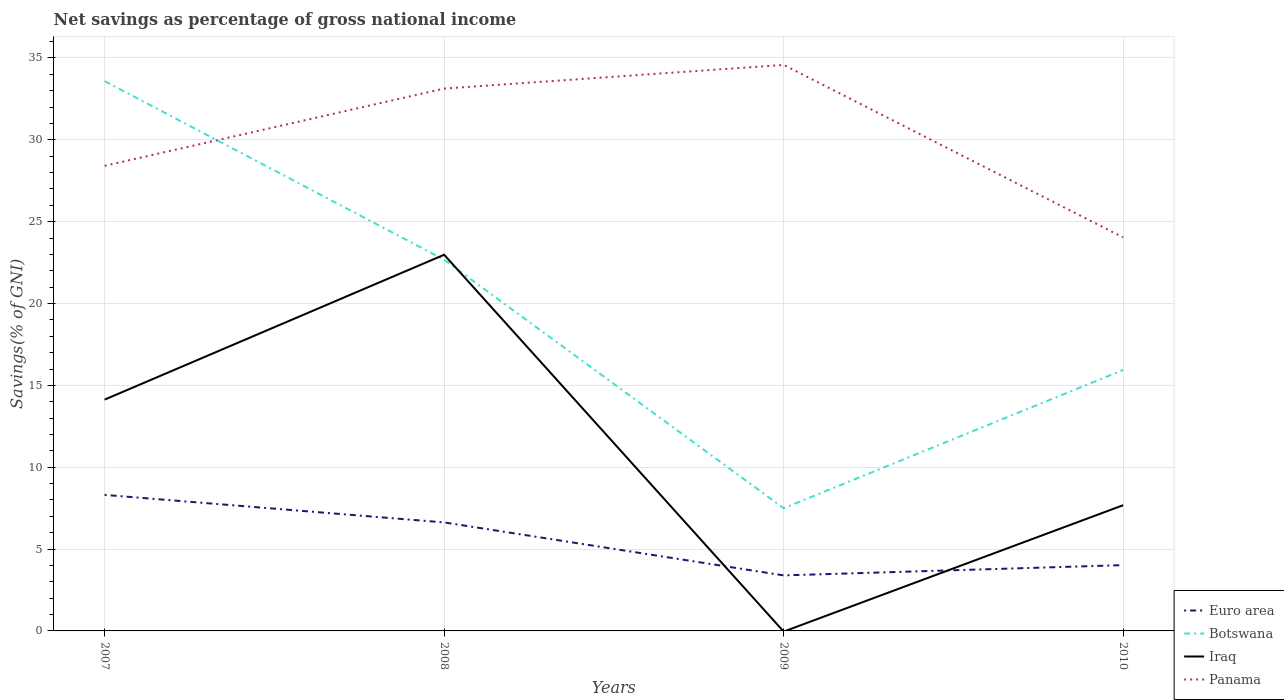How many different coloured lines are there?
Offer a very short reply. 4. Does the line corresponding to Euro area intersect with the line corresponding to Botswana?
Your answer should be very brief. No. Is the number of lines equal to the number of legend labels?
Your response must be concise. No. What is the total total savings in Euro area in the graph?
Provide a succinct answer. 1.68. What is the difference between the highest and the second highest total savings in Botswana?
Your answer should be compact. 26.09. Is the total savings in Botswana strictly greater than the total savings in Panama over the years?
Offer a very short reply. No. How many lines are there?
Provide a succinct answer. 4. How many years are there in the graph?
Your response must be concise. 4. What is the difference between two consecutive major ticks on the Y-axis?
Your answer should be very brief. 5. Are the values on the major ticks of Y-axis written in scientific E-notation?
Keep it short and to the point. No. Does the graph contain any zero values?
Keep it short and to the point. Yes. How are the legend labels stacked?
Ensure brevity in your answer.  Vertical. What is the title of the graph?
Keep it short and to the point. Net savings as percentage of gross national income. What is the label or title of the X-axis?
Offer a terse response. Years. What is the label or title of the Y-axis?
Offer a very short reply. Savings(% of GNI). What is the Savings(% of GNI) in Euro area in 2007?
Make the answer very short. 8.31. What is the Savings(% of GNI) of Botswana in 2007?
Your response must be concise. 33.59. What is the Savings(% of GNI) in Iraq in 2007?
Provide a short and direct response. 14.13. What is the Savings(% of GNI) in Panama in 2007?
Keep it short and to the point. 28.41. What is the Savings(% of GNI) in Euro area in 2008?
Offer a terse response. 6.63. What is the Savings(% of GNI) of Botswana in 2008?
Ensure brevity in your answer.  22.68. What is the Savings(% of GNI) in Iraq in 2008?
Keep it short and to the point. 22.98. What is the Savings(% of GNI) of Panama in 2008?
Offer a terse response. 33.13. What is the Savings(% of GNI) in Euro area in 2009?
Give a very brief answer. 3.39. What is the Savings(% of GNI) of Botswana in 2009?
Offer a very short reply. 7.5. What is the Savings(% of GNI) in Panama in 2009?
Your answer should be compact. 34.58. What is the Savings(% of GNI) in Euro area in 2010?
Ensure brevity in your answer.  4.02. What is the Savings(% of GNI) of Botswana in 2010?
Offer a terse response. 15.94. What is the Savings(% of GNI) of Iraq in 2010?
Your response must be concise. 7.68. What is the Savings(% of GNI) of Panama in 2010?
Your response must be concise. 24.04. Across all years, what is the maximum Savings(% of GNI) of Euro area?
Make the answer very short. 8.31. Across all years, what is the maximum Savings(% of GNI) of Botswana?
Your answer should be very brief. 33.59. Across all years, what is the maximum Savings(% of GNI) in Iraq?
Keep it short and to the point. 22.98. Across all years, what is the maximum Savings(% of GNI) of Panama?
Give a very brief answer. 34.58. Across all years, what is the minimum Savings(% of GNI) in Euro area?
Ensure brevity in your answer.  3.39. Across all years, what is the minimum Savings(% of GNI) of Botswana?
Ensure brevity in your answer.  7.5. Across all years, what is the minimum Savings(% of GNI) in Iraq?
Provide a short and direct response. 0. Across all years, what is the minimum Savings(% of GNI) of Panama?
Offer a very short reply. 24.04. What is the total Savings(% of GNI) of Euro area in the graph?
Ensure brevity in your answer.  22.35. What is the total Savings(% of GNI) of Botswana in the graph?
Provide a short and direct response. 79.7. What is the total Savings(% of GNI) of Iraq in the graph?
Provide a short and direct response. 44.79. What is the total Savings(% of GNI) of Panama in the graph?
Provide a short and direct response. 120.16. What is the difference between the Savings(% of GNI) of Euro area in 2007 and that in 2008?
Your response must be concise. 1.68. What is the difference between the Savings(% of GNI) in Botswana in 2007 and that in 2008?
Your answer should be compact. 10.91. What is the difference between the Savings(% of GNI) in Iraq in 2007 and that in 2008?
Your response must be concise. -8.85. What is the difference between the Savings(% of GNI) in Panama in 2007 and that in 2008?
Provide a short and direct response. -4.72. What is the difference between the Savings(% of GNI) in Euro area in 2007 and that in 2009?
Keep it short and to the point. 4.92. What is the difference between the Savings(% of GNI) in Botswana in 2007 and that in 2009?
Provide a succinct answer. 26.09. What is the difference between the Savings(% of GNI) in Panama in 2007 and that in 2009?
Offer a terse response. -6.16. What is the difference between the Savings(% of GNI) of Euro area in 2007 and that in 2010?
Offer a very short reply. 4.29. What is the difference between the Savings(% of GNI) in Botswana in 2007 and that in 2010?
Keep it short and to the point. 17.64. What is the difference between the Savings(% of GNI) of Iraq in 2007 and that in 2010?
Give a very brief answer. 6.45. What is the difference between the Savings(% of GNI) in Panama in 2007 and that in 2010?
Give a very brief answer. 4.37. What is the difference between the Savings(% of GNI) in Euro area in 2008 and that in 2009?
Provide a short and direct response. 3.24. What is the difference between the Savings(% of GNI) in Botswana in 2008 and that in 2009?
Your answer should be compact. 15.18. What is the difference between the Savings(% of GNI) of Panama in 2008 and that in 2009?
Provide a short and direct response. -1.45. What is the difference between the Savings(% of GNI) in Euro area in 2008 and that in 2010?
Your response must be concise. 2.61. What is the difference between the Savings(% of GNI) of Botswana in 2008 and that in 2010?
Provide a short and direct response. 6.74. What is the difference between the Savings(% of GNI) of Iraq in 2008 and that in 2010?
Your answer should be very brief. 15.3. What is the difference between the Savings(% of GNI) in Panama in 2008 and that in 2010?
Offer a very short reply. 9.09. What is the difference between the Savings(% of GNI) of Euro area in 2009 and that in 2010?
Provide a succinct answer. -0.63. What is the difference between the Savings(% of GNI) in Botswana in 2009 and that in 2010?
Your answer should be very brief. -8.45. What is the difference between the Savings(% of GNI) of Panama in 2009 and that in 2010?
Your answer should be very brief. 10.54. What is the difference between the Savings(% of GNI) of Euro area in 2007 and the Savings(% of GNI) of Botswana in 2008?
Provide a succinct answer. -14.37. What is the difference between the Savings(% of GNI) of Euro area in 2007 and the Savings(% of GNI) of Iraq in 2008?
Your response must be concise. -14.67. What is the difference between the Savings(% of GNI) of Euro area in 2007 and the Savings(% of GNI) of Panama in 2008?
Give a very brief answer. -24.82. What is the difference between the Savings(% of GNI) of Botswana in 2007 and the Savings(% of GNI) of Iraq in 2008?
Make the answer very short. 10.61. What is the difference between the Savings(% of GNI) of Botswana in 2007 and the Savings(% of GNI) of Panama in 2008?
Your response must be concise. 0.45. What is the difference between the Savings(% of GNI) of Iraq in 2007 and the Savings(% of GNI) of Panama in 2008?
Offer a very short reply. -19. What is the difference between the Savings(% of GNI) in Euro area in 2007 and the Savings(% of GNI) in Botswana in 2009?
Make the answer very short. 0.82. What is the difference between the Savings(% of GNI) in Euro area in 2007 and the Savings(% of GNI) in Panama in 2009?
Your answer should be compact. -26.27. What is the difference between the Savings(% of GNI) in Botswana in 2007 and the Savings(% of GNI) in Panama in 2009?
Provide a succinct answer. -0.99. What is the difference between the Savings(% of GNI) of Iraq in 2007 and the Savings(% of GNI) of Panama in 2009?
Provide a succinct answer. -20.45. What is the difference between the Savings(% of GNI) in Euro area in 2007 and the Savings(% of GNI) in Botswana in 2010?
Your response must be concise. -7.63. What is the difference between the Savings(% of GNI) in Euro area in 2007 and the Savings(% of GNI) in Iraq in 2010?
Offer a terse response. 0.63. What is the difference between the Savings(% of GNI) of Euro area in 2007 and the Savings(% of GNI) of Panama in 2010?
Give a very brief answer. -15.73. What is the difference between the Savings(% of GNI) of Botswana in 2007 and the Savings(% of GNI) of Iraq in 2010?
Your answer should be very brief. 25.9. What is the difference between the Savings(% of GNI) in Botswana in 2007 and the Savings(% of GNI) in Panama in 2010?
Make the answer very short. 9.55. What is the difference between the Savings(% of GNI) in Iraq in 2007 and the Savings(% of GNI) in Panama in 2010?
Your answer should be compact. -9.91. What is the difference between the Savings(% of GNI) in Euro area in 2008 and the Savings(% of GNI) in Botswana in 2009?
Your answer should be very brief. -0.87. What is the difference between the Savings(% of GNI) of Euro area in 2008 and the Savings(% of GNI) of Panama in 2009?
Provide a short and direct response. -27.95. What is the difference between the Savings(% of GNI) of Botswana in 2008 and the Savings(% of GNI) of Panama in 2009?
Offer a terse response. -11.9. What is the difference between the Savings(% of GNI) in Iraq in 2008 and the Savings(% of GNI) in Panama in 2009?
Give a very brief answer. -11.6. What is the difference between the Savings(% of GNI) of Euro area in 2008 and the Savings(% of GNI) of Botswana in 2010?
Make the answer very short. -9.31. What is the difference between the Savings(% of GNI) of Euro area in 2008 and the Savings(% of GNI) of Iraq in 2010?
Offer a terse response. -1.05. What is the difference between the Savings(% of GNI) in Euro area in 2008 and the Savings(% of GNI) in Panama in 2010?
Your answer should be compact. -17.41. What is the difference between the Savings(% of GNI) of Botswana in 2008 and the Savings(% of GNI) of Iraq in 2010?
Your answer should be compact. 15. What is the difference between the Savings(% of GNI) of Botswana in 2008 and the Savings(% of GNI) of Panama in 2010?
Keep it short and to the point. -1.36. What is the difference between the Savings(% of GNI) of Iraq in 2008 and the Savings(% of GNI) of Panama in 2010?
Give a very brief answer. -1.06. What is the difference between the Savings(% of GNI) in Euro area in 2009 and the Savings(% of GNI) in Botswana in 2010?
Offer a terse response. -12.55. What is the difference between the Savings(% of GNI) in Euro area in 2009 and the Savings(% of GNI) in Iraq in 2010?
Ensure brevity in your answer.  -4.29. What is the difference between the Savings(% of GNI) in Euro area in 2009 and the Savings(% of GNI) in Panama in 2010?
Ensure brevity in your answer.  -20.65. What is the difference between the Savings(% of GNI) in Botswana in 2009 and the Savings(% of GNI) in Iraq in 2010?
Provide a short and direct response. -0.19. What is the difference between the Savings(% of GNI) in Botswana in 2009 and the Savings(% of GNI) in Panama in 2010?
Your answer should be compact. -16.54. What is the average Savings(% of GNI) in Euro area per year?
Provide a succinct answer. 5.59. What is the average Savings(% of GNI) in Botswana per year?
Provide a short and direct response. 19.92. What is the average Savings(% of GNI) in Iraq per year?
Ensure brevity in your answer.  11.2. What is the average Savings(% of GNI) of Panama per year?
Ensure brevity in your answer.  30.04. In the year 2007, what is the difference between the Savings(% of GNI) of Euro area and Savings(% of GNI) of Botswana?
Keep it short and to the point. -25.28. In the year 2007, what is the difference between the Savings(% of GNI) of Euro area and Savings(% of GNI) of Iraq?
Your answer should be very brief. -5.82. In the year 2007, what is the difference between the Savings(% of GNI) of Euro area and Savings(% of GNI) of Panama?
Your response must be concise. -20.1. In the year 2007, what is the difference between the Savings(% of GNI) in Botswana and Savings(% of GNI) in Iraq?
Provide a short and direct response. 19.46. In the year 2007, what is the difference between the Savings(% of GNI) in Botswana and Savings(% of GNI) in Panama?
Your answer should be compact. 5.17. In the year 2007, what is the difference between the Savings(% of GNI) of Iraq and Savings(% of GNI) of Panama?
Make the answer very short. -14.28. In the year 2008, what is the difference between the Savings(% of GNI) in Euro area and Savings(% of GNI) in Botswana?
Make the answer very short. -16.05. In the year 2008, what is the difference between the Savings(% of GNI) of Euro area and Savings(% of GNI) of Iraq?
Your answer should be very brief. -16.35. In the year 2008, what is the difference between the Savings(% of GNI) of Euro area and Savings(% of GNI) of Panama?
Offer a very short reply. -26.5. In the year 2008, what is the difference between the Savings(% of GNI) of Botswana and Savings(% of GNI) of Iraq?
Provide a succinct answer. -0.3. In the year 2008, what is the difference between the Savings(% of GNI) in Botswana and Savings(% of GNI) in Panama?
Offer a very short reply. -10.45. In the year 2008, what is the difference between the Savings(% of GNI) in Iraq and Savings(% of GNI) in Panama?
Your answer should be very brief. -10.15. In the year 2009, what is the difference between the Savings(% of GNI) in Euro area and Savings(% of GNI) in Botswana?
Provide a succinct answer. -4.1. In the year 2009, what is the difference between the Savings(% of GNI) in Euro area and Savings(% of GNI) in Panama?
Your response must be concise. -31.19. In the year 2009, what is the difference between the Savings(% of GNI) in Botswana and Savings(% of GNI) in Panama?
Your answer should be compact. -27.08. In the year 2010, what is the difference between the Savings(% of GNI) in Euro area and Savings(% of GNI) in Botswana?
Provide a short and direct response. -11.92. In the year 2010, what is the difference between the Savings(% of GNI) of Euro area and Savings(% of GNI) of Iraq?
Offer a terse response. -3.66. In the year 2010, what is the difference between the Savings(% of GNI) of Euro area and Savings(% of GNI) of Panama?
Ensure brevity in your answer.  -20.02. In the year 2010, what is the difference between the Savings(% of GNI) in Botswana and Savings(% of GNI) in Iraq?
Keep it short and to the point. 8.26. In the year 2010, what is the difference between the Savings(% of GNI) of Botswana and Savings(% of GNI) of Panama?
Provide a succinct answer. -8.1. In the year 2010, what is the difference between the Savings(% of GNI) of Iraq and Savings(% of GNI) of Panama?
Ensure brevity in your answer.  -16.36. What is the ratio of the Savings(% of GNI) in Euro area in 2007 to that in 2008?
Your response must be concise. 1.25. What is the ratio of the Savings(% of GNI) of Botswana in 2007 to that in 2008?
Give a very brief answer. 1.48. What is the ratio of the Savings(% of GNI) of Iraq in 2007 to that in 2008?
Your answer should be compact. 0.61. What is the ratio of the Savings(% of GNI) in Panama in 2007 to that in 2008?
Your answer should be very brief. 0.86. What is the ratio of the Savings(% of GNI) in Euro area in 2007 to that in 2009?
Your answer should be very brief. 2.45. What is the ratio of the Savings(% of GNI) of Botswana in 2007 to that in 2009?
Offer a very short reply. 4.48. What is the ratio of the Savings(% of GNI) in Panama in 2007 to that in 2009?
Make the answer very short. 0.82. What is the ratio of the Savings(% of GNI) in Euro area in 2007 to that in 2010?
Keep it short and to the point. 2.07. What is the ratio of the Savings(% of GNI) of Botswana in 2007 to that in 2010?
Your response must be concise. 2.11. What is the ratio of the Savings(% of GNI) of Iraq in 2007 to that in 2010?
Your answer should be very brief. 1.84. What is the ratio of the Savings(% of GNI) of Panama in 2007 to that in 2010?
Your answer should be compact. 1.18. What is the ratio of the Savings(% of GNI) in Euro area in 2008 to that in 2009?
Your answer should be very brief. 1.95. What is the ratio of the Savings(% of GNI) in Botswana in 2008 to that in 2009?
Ensure brevity in your answer.  3.03. What is the ratio of the Savings(% of GNI) in Panama in 2008 to that in 2009?
Give a very brief answer. 0.96. What is the ratio of the Savings(% of GNI) of Euro area in 2008 to that in 2010?
Provide a short and direct response. 1.65. What is the ratio of the Savings(% of GNI) in Botswana in 2008 to that in 2010?
Give a very brief answer. 1.42. What is the ratio of the Savings(% of GNI) of Iraq in 2008 to that in 2010?
Offer a terse response. 2.99. What is the ratio of the Savings(% of GNI) of Panama in 2008 to that in 2010?
Keep it short and to the point. 1.38. What is the ratio of the Savings(% of GNI) of Euro area in 2009 to that in 2010?
Provide a short and direct response. 0.84. What is the ratio of the Savings(% of GNI) of Botswana in 2009 to that in 2010?
Offer a terse response. 0.47. What is the ratio of the Savings(% of GNI) of Panama in 2009 to that in 2010?
Provide a short and direct response. 1.44. What is the difference between the highest and the second highest Savings(% of GNI) in Euro area?
Ensure brevity in your answer.  1.68. What is the difference between the highest and the second highest Savings(% of GNI) in Botswana?
Offer a terse response. 10.91. What is the difference between the highest and the second highest Savings(% of GNI) of Iraq?
Provide a succinct answer. 8.85. What is the difference between the highest and the second highest Savings(% of GNI) in Panama?
Your answer should be compact. 1.45. What is the difference between the highest and the lowest Savings(% of GNI) in Euro area?
Provide a succinct answer. 4.92. What is the difference between the highest and the lowest Savings(% of GNI) of Botswana?
Ensure brevity in your answer.  26.09. What is the difference between the highest and the lowest Savings(% of GNI) in Iraq?
Provide a short and direct response. 22.98. What is the difference between the highest and the lowest Savings(% of GNI) in Panama?
Provide a short and direct response. 10.54. 